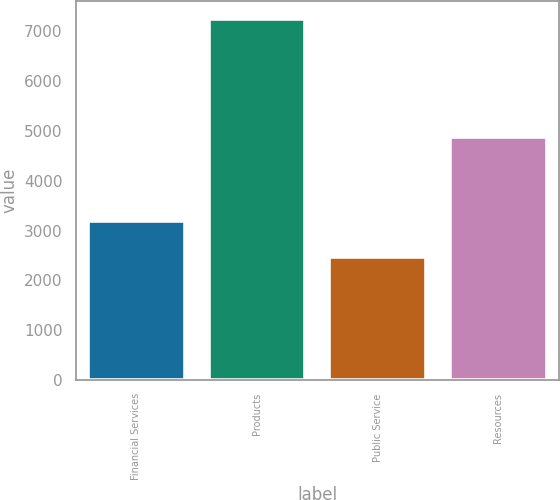<chart> <loc_0><loc_0><loc_500><loc_500><bar_chart><fcel>Financial Services<fcel>Products<fcel>Public Service<fcel>Resources<nl><fcel>3189<fcel>7247<fcel>2475<fcel>4888<nl></chart> 